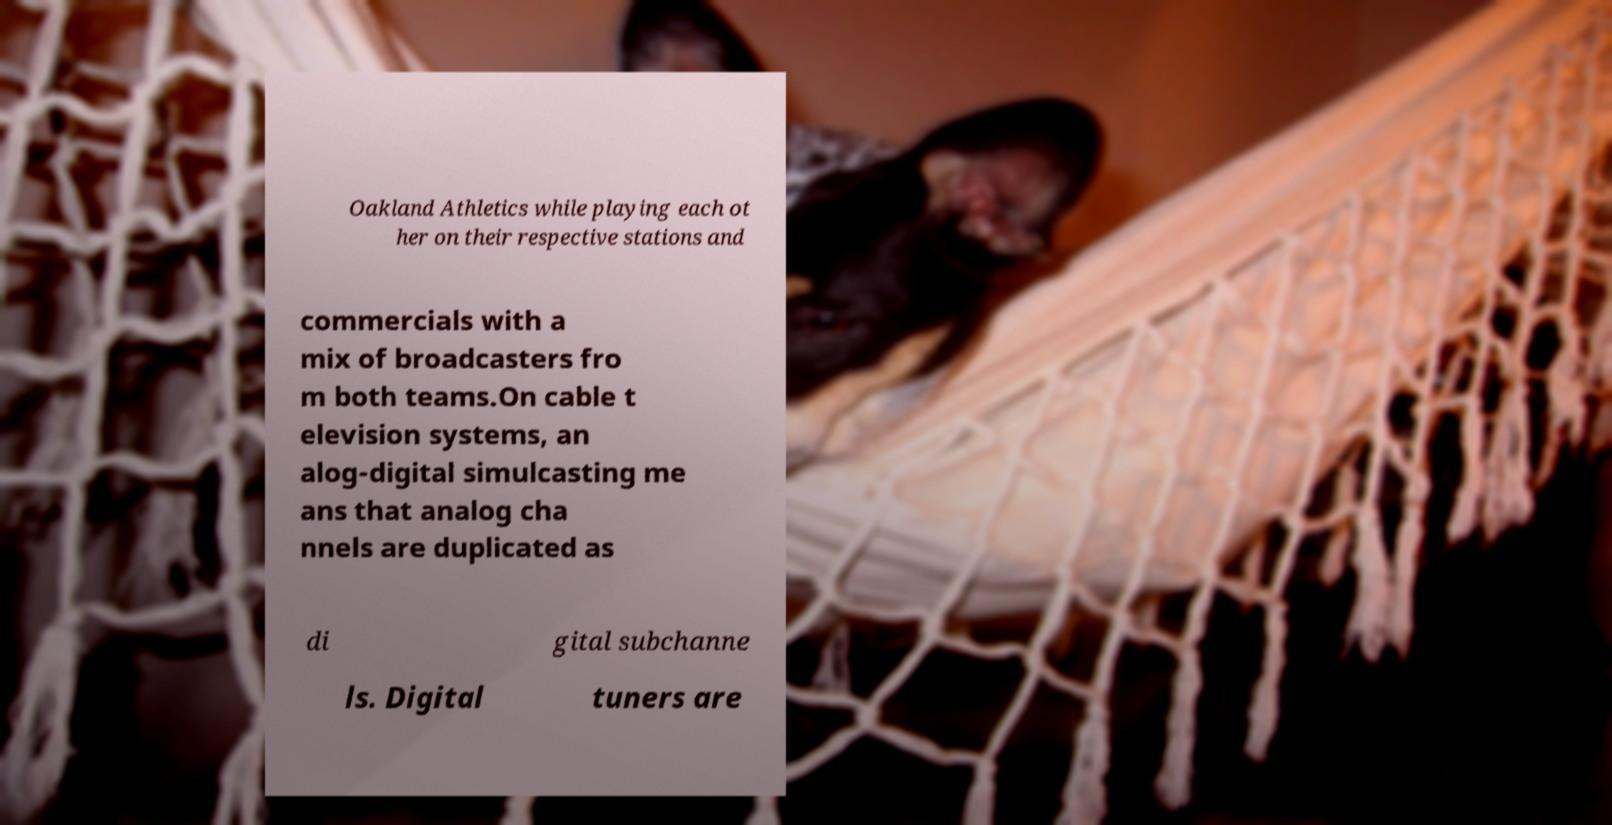What messages or text are displayed in this image? I need them in a readable, typed format. Oakland Athletics while playing each ot her on their respective stations and commercials with a mix of broadcasters fro m both teams.On cable t elevision systems, an alog-digital simulcasting me ans that analog cha nnels are duplicated as di gital subchanne ls. Digital tuners are 